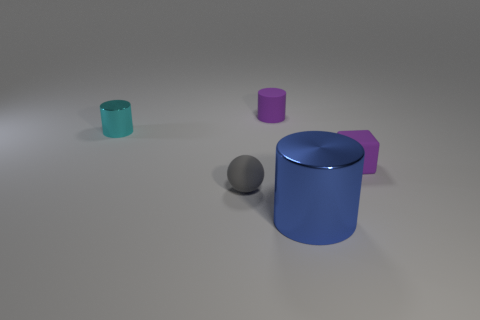Is there a tiny purple ball made of the same material as the large blue object?
Make the answer very short. No. There is a gray object that is the same size as the cyan cylinder; what is it made of?
Provide a succinct answer. Rubber. The tiny thing on the right side of the shiny thing in front of the shiny cylinder behind the gray matte ball is what color?
Provide a succinct answer. Purple. Do the small matte thing behind the small cyan cylinder and the small shiny object left of the purple rubber cylinder have the same shape?
Your answer should be compact. Yes. What number of big brown metallic balls are there?
Your response must be concise. 0. What color is the shiny cylinder that is the same size as the cube?
Provide a succinct answer. Cyan. Does the purple object that is on the right side of the blue cylinder have the same material as the small cylinder that is on the left side of the small gray thing?
Give a very brief answer. No. What is the size of the rubber object that is behind the small rubber thing that is right of the tiny matte cylinder?
Provide a short and direct response. Small. What is the material of the cylinder that is in front of the small gray ball?
Provide a short and direct response. Metal. What number of things are either small rubber things to the right of the large blue metallic object or things to the right of the gray matte object?
Provide a short and direct response. 3. 